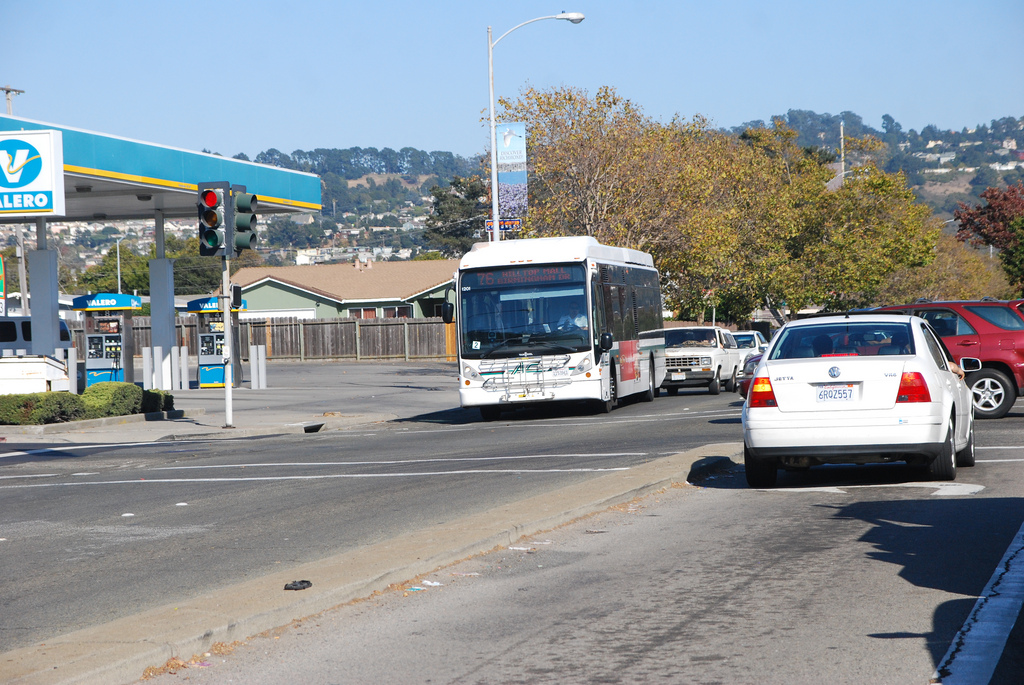Is the fence that is to the left of the car dark and metallic? No, the fence to the left of the car is neither dark nor metallic; it is a lighter brown wooden fence. 